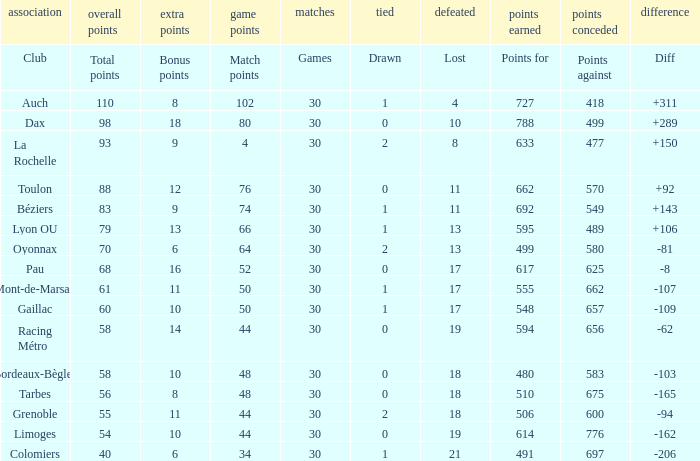What is the number of games for a club that has 34 match points? 30.0. 